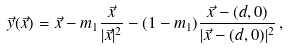Convert formula to latex. <formula><loc_0><loc_0><loc_500><loc_500>\vec { y } ( \vec { x } ) = \vec { x } - m _ { 1 } \frac { \vec { x } } { | \vec { x } | ^ { 2 } } - ( 1 - m _ { 1 } ) \frac { \vec { x } - ( d , 0 ) } { | \vec { x } - ( d , 0 ) | ^ { 2 } } \, ,</formula> 